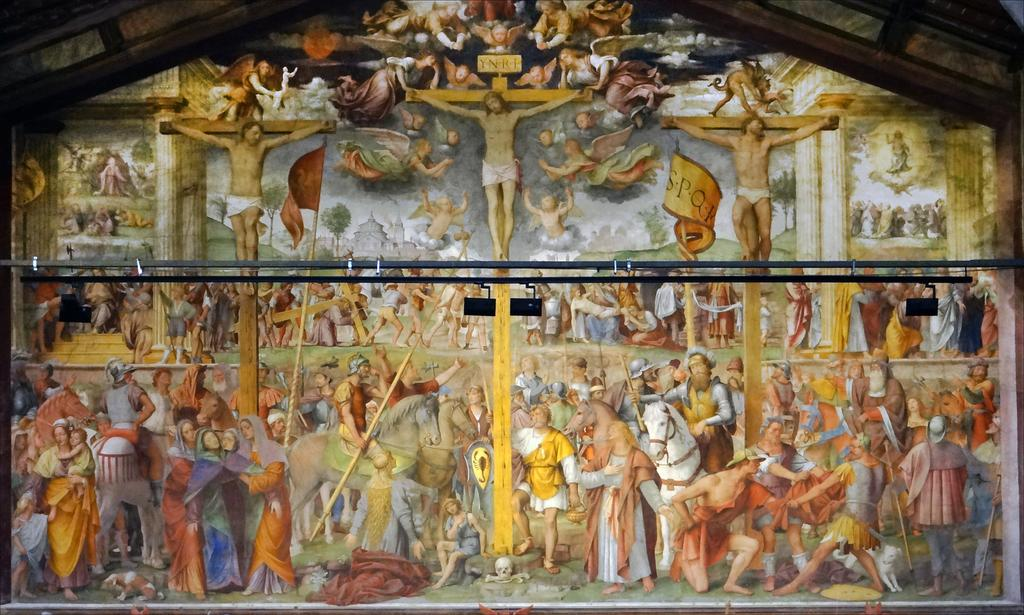What types of subjects are depicted in the paintings in the image? The image contains different paintings of people and horses. Is there a specific painting that stands out in the image? Yes, there is a picture of Jesus Christ at the center of the image. What type of fairies can be seen flying around the paintings in the image? There are no fairies present in the image; it only contains paintings of people, horses, and Jesus Christ. 